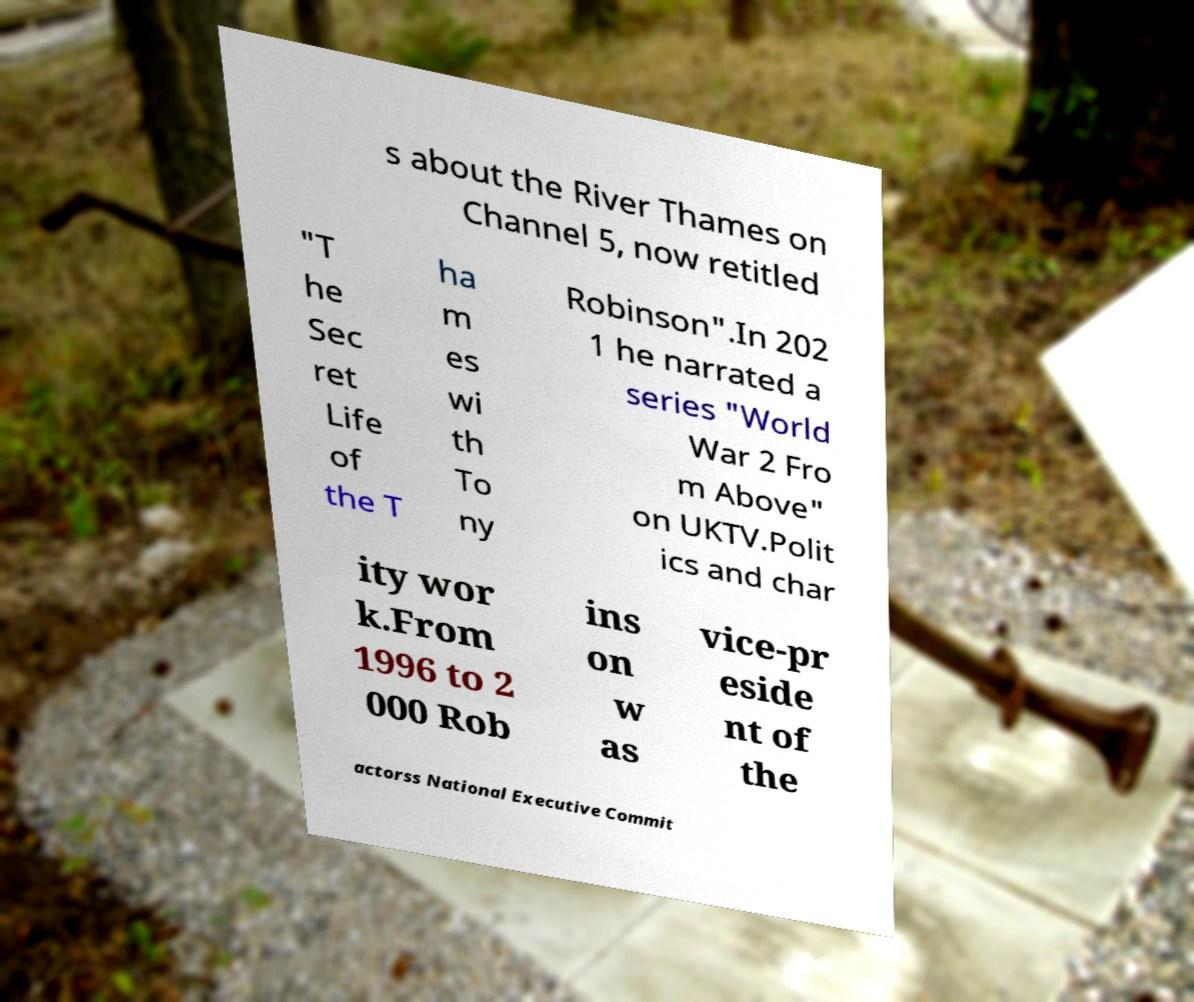Can you accurately transcribe the text from the provided image for me? s about the River Thames on Channel 5, now retitled "T he Sec ret Life of the T ha m es wi th To ny Robinson".In 202 1 he narrated a series "World War 2 Fro m Above" on UKTV.Polit ics and char ity wor k.From 1996 to 2 000 Rob ins on w as vice-pr eside nt of the actorss National Executive Commit 